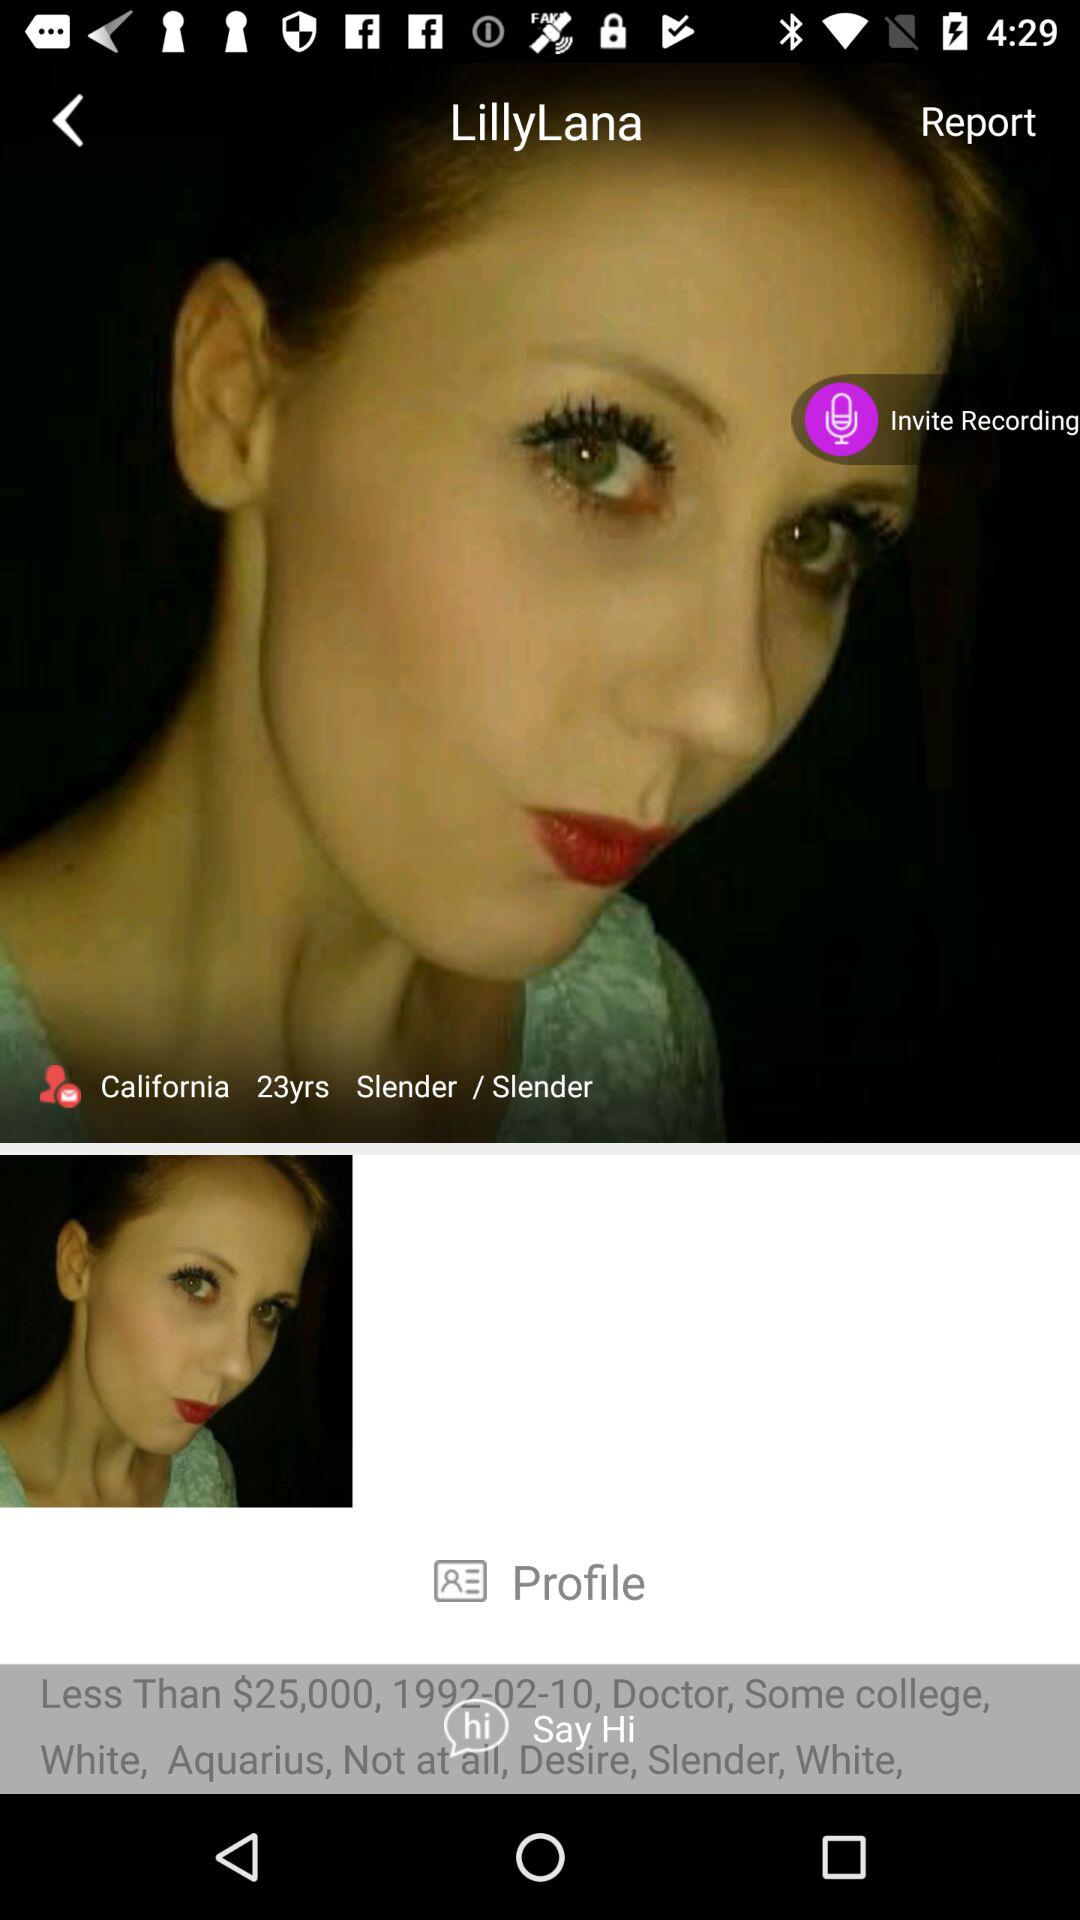How many more years does this person have until they are 30?
Answer the question using a single word or phrase. 7 